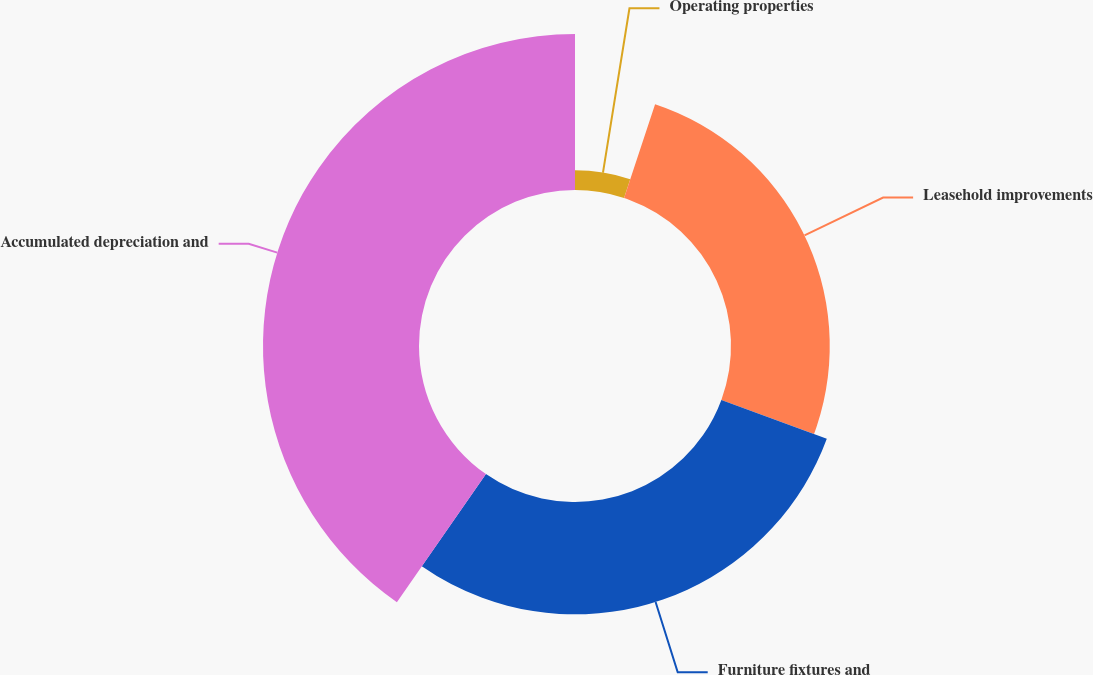<chart> <loc_0><loc_0><loc_500><loc_500><pie_chart><fcel>Operating properties<fcel>Leasehold improvements<fcel>Furniture fixtures and<fcel>Accumulated depreciation and<nl><fcel>5.09%<fcel>25.53%<fcel>29.05%<fcel>40.33%<nl></chart> 